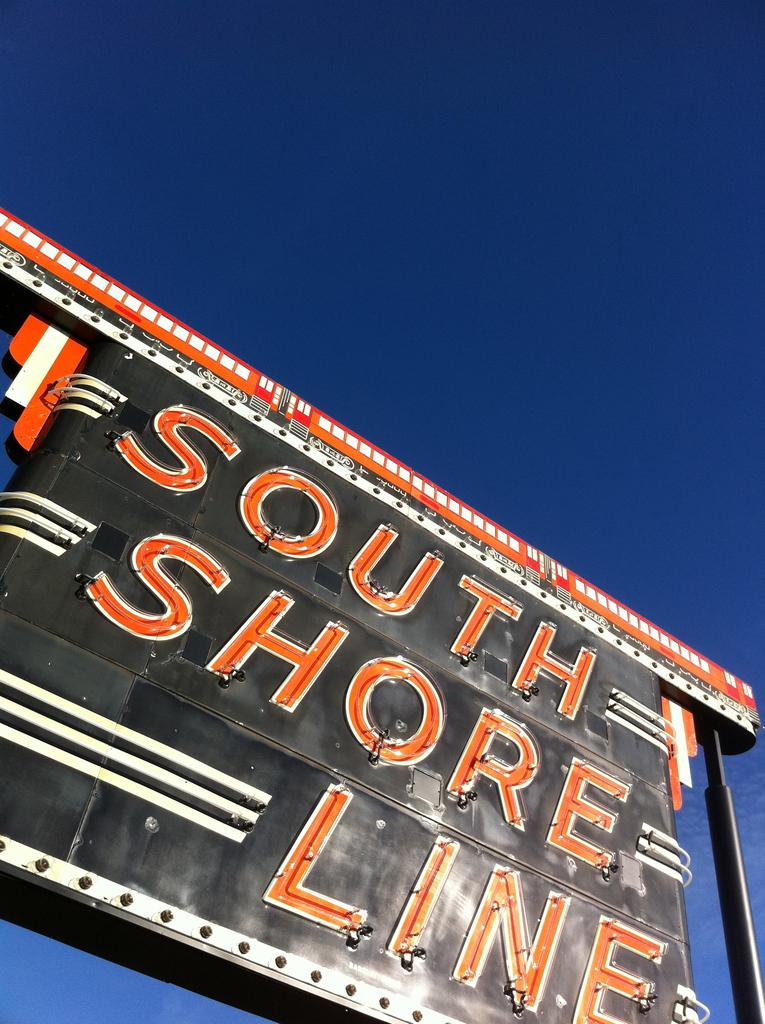Provide a one-sentence caption for the provided image. Black, white, and orange South Shore Line sign. 